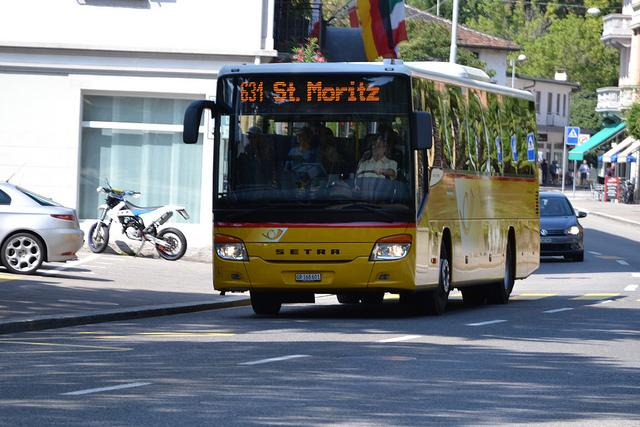What is the speed limit of school bus? fifteen mph 